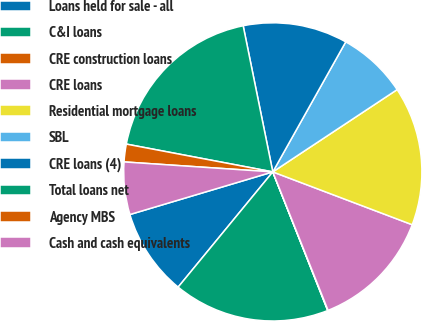<chart> <loc_0><loc_0><loc_500><loc_500><pie_chart><fcel>Loans held for sale - all<fcel>C&I loans<fcel>CRE construction loans<fcel>CRE loans<fcel>Residential mortgage loans<fcel>SBL<fcel>CRE loans (4)<fcel>Total loans net<fcel>Agency MBS<fcel>Cash and cash equivalents<nl><fcel>9.44%<fcel>16.95%<fcel>0.04%<fcel>13.19%<fcel>15.07%<fcel>7.56%<fcel>11.32%<fcel>18.83%<fcel>1.92%<fcel>5.68%<nl></chart> 